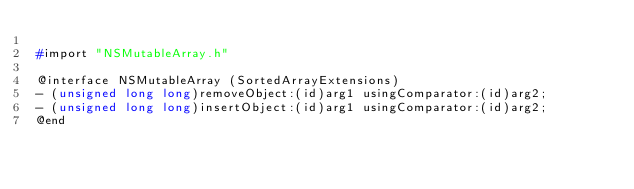<code> <loc_0><loc_0><loc_500><loc_500><_C_>
#import "NSMutableArray.h"

@interface NSMutableArray (SortedArrayExtensions)
- (unsigned long long)removeObject:(id)arg1 usingComparator:(id)arg2;
- (unsigned long long)insertObject:(id)arg1 usingComparator:(id)arg2;
@end

</code> 